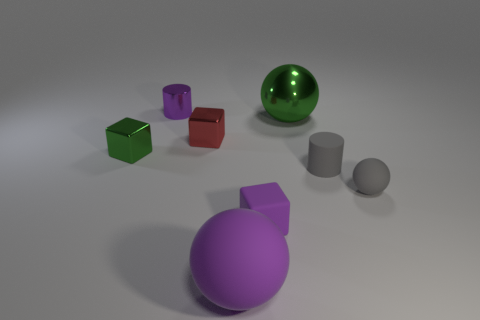Subtract all small matte spheres. How many spheres are left? 2 Subtract 1 cubes. How many cubes are left? 2 Add 1 yellow blocks. How many objects exist? 9 Subtract all blocks. Subtract all large purple matte balls. How many objects are left? 4 Add 6 blocks. How many blocks are left? 9 Add 3 small purple rubber blocks. How many small purple rubber blocks exist? 4 Subtract 0 yellow balls. How many objects are left? 8 Subtract all blocks. How many objects are left? 5 Subtract all yellow spheres. Subtract all blue cubes. How many spheres are left? 3 